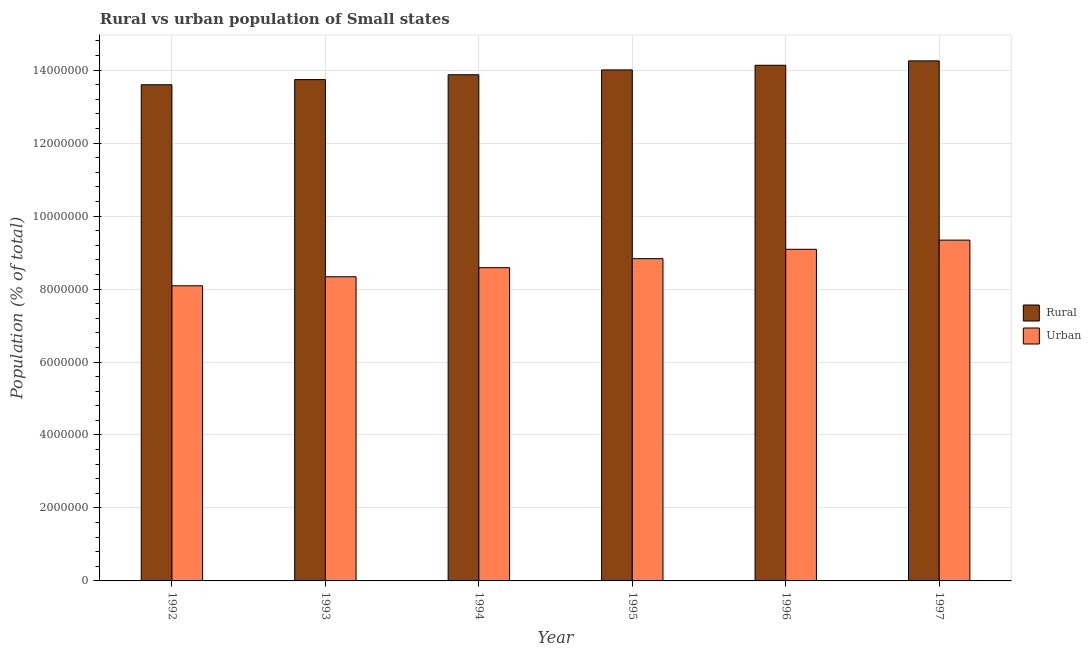How many groups of bars are there?
Ensure brevity in your answer.  6. Are the number of bars on each tick of the X-axis equal?
Your answer should be very brief. Yes. How many bars are there on the 2nd tick from the left?
Give a very brief answer. 2. How many bars are there on the 5th tick from the right?
Your answer should be very brief. 2. What is the label of the 6th group of bars from the left?
Your answer should be compact. 1997. What is the rural population density in 1995?
Your response must be concise. 1.40e+07. Across all years, what is the maximum urban population density?
Give a very brief answer. 9.34e+06. Across all years, what is the minimum rural population density?
Your answer should be compact. 1.36e+07. In which year was the urban population density minimum?
Keep it short and to the point. 1992. What is the total urban population density in the graph?
Your response must be concise. 5.23e+07. What is the difference between the urban population density in 1996 and that in 1997?
Your answer should be compact. -2.51e+05. What is the difference between the urban population density in 1996 and the rural population density in 1995?
Provide a succinct answer. 2.57e+05. What is the average urban population density per year?
Give a very brief answer. 8.71e+06. What is the ratio of the rural population density in 1993 to that in 1995?
Your answer should be very brief. 0.98. Is the rural population density in 1995 less than that in 1997?
Offer a very short reply. Yes. What is the difference between the highest and the second highest urban population density?
Your answer should be very brief. 2.51e+05. What is the difference between the highest and the lowest urban population density?
Make the answer very short. 1.25e+06. In how many years, is the urban population density greater than the average urban population density taken over all years?
Give a very brief answer. 3. What does the 1st bar from the left in 1992 represents?
Offer a terse response. Rural. What does the 2nd bar from the right in 1997 represents?
Your answer should be compact. Rural. Are all the bars in the graph horizontal?
Offer a very short reply. No. How many years are there in the graph?
Offer a terse response. 6. Does the graph contain any zero values?
Offer a terse response. No. How are the legend labels stacked?
Ensure brevity in your answer.  Vertical. What is the title of the graph?
Your answer should be compact. Rural vs urban population of Small states. What is the label or title of the Y-axis?
Provide a short and direct response. Population (% of total). What is the Population (% of total) of Rural in 1992?
Make the answer very short. 1.36e+07. What is the Population (% of total) in Urban in 1992?
Give a very brief answer. 8.09e+06. What is the Population (% of total) in Rural in 1993?
Give a very brief answer. 1.37e+07. What is the Population (% of total) of Urban in 1993?
Keep it short and to the point. 8.34e+06. What is the Population (% of total) in Rural in 1994?
Provide a short and direct response. 1.39e+07. What is the Population (% of total) of Urban in 1994?
Your answer should be compact. 8.59e+06. What is the Population (% of total) of Rural in 1995?
Offer a very short reply. 1.40e+07. What is the Population (% of total) of Urban in 1995?
Offer a terse response. 8.83e+06. What is the Population (% of total) of Rural in 1996?
Make the answer very short. 1.41e+07. What is the Population (% of total) of Urban in 1996?
Ensure brevity in your answer.  9.09e+06. What is the Population (% of total) of Rural in 1997?
Provide a short and direct response. 1.43e+07. What is the Population (% of total) of Urban in 1997?
Provide a short and direct response. 9.34e+06. Across all years, what is the maximum Population (% of total) in Rural?
Give a very brief answer. 1.43e+07. Across all years, what is the maximum Population (% of total) in Urban?
Provide a succinct answer. 9.34e+06. Across all years, what is the minimum Population (% of total) of Rural?
Offer a terse response. 1.36e+07. Across all years, what is the minimum Population (% of total) in Urban?
Give a very brief answer. 8.09e+06. What is the total Population (% of total) of Rural in the graph?
Your response must be concise. 8.36e+07. What is the total Population (% of total) of Urban in the graph?
Provide a succinct answer. 5.23e+07. What is the difference between the Population (% of total) in Rural in 1992 and that in 1993?
Your answer should be very brief. -1.41e+05. What is the difference between the Population (% of total) in Urban in 1992 and that in 1993?
Give a very brief answer. -2.48e+05. What is the difference between the Population (% of total) in Rural in 1992 and that in 1994?
Provide a succinct answer. -2.75e+05. What is the difference between the Population (% of total) in Urban in 1992 and that in 1994?
Offer a very short reply. -4.96e+05. What is the difference between the Population (% of total) in Rural in 1992 and that in 1995?
Offer a terse response. -4.07e+05. What is the difference between the Population (% of total) of Urban in 1992 and that in 1995?
Give a very brief answer. -7.44e+05. What is the difference between the Population (% of total) in Rural in 1992 and that in 1996?
Your answer should be compact. -5.34e+05. What is the difference between the Population (% of total) in Urban in 1992 and that in 1996?
Your answer should be compact. -1.00e+06. What is the difference between the Population (% of total) in Rural in 1992 and that in 1997?
Offer a terse response. -6.55e+05. What is the difference between the Population (% of total) of Urban in 1992 and that in 1997?
Provide a succinct answer. -1.25e+06. What is the difference between the Population (% of total) in Rural in 1993 and that in 1994?
Offer a very short reply. -1.33e+05. What is the difference between the Population (% of total) in Urban in 1993 and that in 1994?
Ensure brevity in your answer.  -2.49e+05. What is the difference between the Population (% of total) in Rural in 1993 and that in 1995?
Your response must be concise. -2.65e+05. What is the difference between the Population (% of total) of Urban in 1993 and that in 1995?
Make the answer very short. -4.97e+05. What is the difference between the Population (% of total) in Rural in 1993 and that in 1996?
Keep it short and to the point. -3.93e+05. What is the difference between the Population (% of total) of Urban in 1993 and that in 1996?
Your answer should be very brief. -7.53e+05. What is the difference between the Population (% of total) of Rural in 1993 and that in 1997?
Provide a short and direct response. -5.13e+05. What is the difference between the Population (% of total) of Urban in 1993 and that in 1997?
Your response must be concise. -1.00e+06. What is the difference between the Population (% of total) of Rural in 1994 and that in 1995?
Your answer should be very brief. -1.32e+05. What is the difference between the Population (% of total) in Urban in 1994 and that in 1995?
Keep it short and to the point. -2.48e+05. What is the difference between the Population (% of total) of Rural in 1994 and that in 1996?
Ensure brevity in your answer.  -2.60e+05. What is the difference between the Population (% of total) of Urban in 1994 and that in 1996?
Provide a short and direct response. -5.04e+05. What is the difference between the Population (% of total) in Rural in 1994 and that in 1997?
Ensure brevity in your answer.  -3.80e+05. What is the difference between the Population (% of total) in Urban in 1994 and that in 1997?
Give a very brief answer. -7.55e+05. What is the difference between the Population (% of total) of Rural in 1995 and that in 1996?
Offer a terse response. -1.28e+05. What is the difference between the Population (% of total) of Urban in 1995 and that in 1996?
Make the answer very short. -2.57e+05. What is the difference between the Population (% of total) of Rural in 1995 and that in 1997?
Provide a succinct answer. -2.48e+05. What is the difference between the Population (% of total) of Urban in 1995 and that in 1997?
Provide a succinct answer. -5.08e+05. What is the difference between the Population (% of total) of Rural in 1996 and that in 1997?
Ensure brevity in your answer.  -1.20e+05. What is the difference between the Population (% of total) in Urban in 1996 and that in 1997?
Ensure brevity in your answer.  -2.51e+05. What is the difference between the Population (% of total) in Rural in 1992 and the Population (% of total) in Urban in 1993?
Ensure brevity in your answer.  5.26e+06. What is the difference between the Population (% of total) of Rural in 1992 and the Population (% of total) of Urban in 1994?
Keep it short and to the point. 5.01e+06. What is the difference between the Population (% of total) in Rural in 1992 and the Population (% of total) in Urban in 1995?
Your answer should be compact. 4.77e+06. What is the difference between the Population (% of total) of Rural in 1992 and the Population (% of total) of Urban in 1996?
Provide a short and direct response. 4.51e+06. What is the difference between the Population (% of total) in Rural in 1992 and the Population (% of total) in Urban in 1997?
Provide a short and direct response. 4.26e+06. What is the difference between the Population (% of total) in Rural in 1993 and the Population (% of total) in Urban in 1994?
Keep it short and to the point. 5.16e+06. What is the difference between the Population (% of total) in Rural in 1993 and the Population (% of total) in Urban in 1995?
Keep it short and to the point. 4.91e+06. What is the difference between the Population (% of total) of Rural in 1993 and the Population (% of total) of Urban in 1996?
Provide a short and direct response. 4.65e+06. What is the difference between the Population (% of total) in Rural in 1993 and the Population (% of total) in Urban in 1997?
Give a very brief answer. 4.40e+06. What is the difference between the Population (% of total) of Rural in 1994 and the Population (% of total) of Urban in 1995?
Provide a succinct answer. 5.04e+06. What is the difference between the Population (% of total) of Rural in 1994 and the Population (% of total) of Urban in 1996?
Your answer should be very brief. 4.78e+06. What is the difference between the Population (% of total) in Rural in 1994 and the Population (% of total) in Urban in 1997?
Your response must be concise. 4.53e+06. What is the difference between the Population (% of total) in Rural in 1995 and the Population (% of total) in Urban in 1996?
Offer a terse response. 4.92e+06. What is the difference between the Population (% of total) in Rural in 1995 and the Population (% of total) in Urban in 1997?
Offer a terse response. 4.67e+06. What is the difference between the Population (% of total) in Rural in 1996 and the Population (% of total) in Urban in 1997?
Your response must be concise. 4.79e+06. What is the average Population (% of total) of Rural per year?
Ensure brevity in your answer.  1.39e+07. What is the average Population (% of total) in Urban per year?
Offer a terse response. 8.71e+06. In the year 1992, what is the difference between the Population (% of total) in Rural and Population (% of total) in Urban?
Provide a succinct answer. 5.51e+06. In the year 1993, what is the difference between the Population (% of total) of Rural and Population (% of total) of Urban?
Your response must be concise. 5.40e+06. In the year 1994, what is the difference between the Population (% of total) of Rural and Population (% of total) of Urban?
Ensure brevity in your answer.  5.29e+06. In the year 1995, what is the difference between the Population (% of total) of Rural and Population (% of total) of Urban?
Offer a very short reply. 5.17e+06. In the year 1996, what is the difference between the Population (% of total) of Rural and Population (% of total) of Urban?
Provide a succinct answer. 5.04e+06. In the year 1997, what is the difference between the Population (% of total) in Rural and Population (% of total) in Urban?
Ensure brevity in your answer.  4.91e+06. What is the ratio of the Population (% of total) in Rural in 1992 to that in 1993?
Provide a short and direct response. 0.99. What is the ratio of the Population (% of total) in Urban in 1992 to that in 1993?
Provide a short and direct response. 0.97. What is the ratio of the Population (% of total) in Rural in 1992 to that in 1994?
Offer a very short reply. 0.98. What is the ratio of the Population (% of total) in Urban in 1992 to that in 1994?
Provide a short and direct response. 0.94. What is the ratio of the Population (% of total) in Rural in 1992 to that in 1995?
Ensure brevity in your answer.  0.97. What is the ratio of the Population (% of total) of Urban in 1992 to that in 1995?
Your answer should be compact. 0.92. What is the ratio of the Population (% of total) in Rural in 1992 to that in 1996?
Provide a succinct answer. 0.96. What is the ratio of the Population (% of total) of Urban in 1992 to that in 1996?
Provide a succinct answer. 0.89. What is the ratio of the Population (% of total) in Rural in 1992 to that in 1997?
Keep it short and to the point. 0.95. What is the ratio of the Population (% of total) in Urban in 1992 to that in 1997?
Offer a terse response. 0.87. What is the ratio of the Population (% of total) in Urban in 1993 to that in 1994?
Keep it short and to the point. 0.97. What is the ratio of the Population (% of total) in Rural in 1993 to that in 1995?
Your response must be concise. 0.98. What is the ratio of the Population (% of total) of Urban in 1993 to that in 1995?
Your response must be concise. 0.94. What is the ratio of the Population (% of total) in Rural in 1993 to that in 1996?
Offer a very short reply. 0.97. What is the ratio of the Population (% of total) in Urban in 1993 to that in 1996?
Make the answer very short. 0.92. What is the ratio of the Population (% of total) of Urban in 1993 to that in 1997?
Your response must be concise. 0.89. What is the ratio of the Population (% of total) in Rural in 1994 to that in 1995?
Your answer should be very brief. 0.99. What is the ratio of the Population (% of total) of Rural in 1994 to that in 1996?
Make the answer very short. 0.98. What is the ratio of the Population (% of total) in Urban in 1994 to that in 1996?
Your response must be concise. 0.94. What is the ratio of the Population (% of total) in Rural in 1994 to that in 1997?
Your answer should be very brief. 0.97. What is the ratio of the Population (% of total) in Urban in 1994 to that in 1997?
Keep it short and to the point. 0.92. What is the ratio of the Population (% of total) in Urban in 1995 to that in 1996?
Provide a short and direct response. 0.97. What is the ratio of the Population (% of total) in Rural in 1995 to that in 1997?
Offer a terse response. 0.98. What is the ratio of the Population (% of total) in Urban in 1995 to that in 1997?
Ensure brevity in your answer.  0.95. What is the ratio of the Population (% of total) of Urban in 1996 to that in 1997?
Provide a succinct answer. 0.97. What is the difference between the highest and the second highest Population (% of total) of Rural?
Offer a very short reply. 1.20e+05. What is the difference between the highest and the second highest Population (% of total) in Urban?
Your response must be concise. 2.51e+05. What is the difference between the highest and the lowest Population (% of total) of Rural?
Provide a succinct answer. 6.55e+05. What is the difference between the highest and the lowest Population (% of total) in Urban?
Keep it short and to the point. 1.25e+06. 